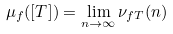Convert formula to latex. <formula><loc_0><loc_0><loc_500><loc_500>\mu _ { f } ( [ T ] ) = \lim _ { n \to \infty } \nu _ { f T } ( n )</formula> 